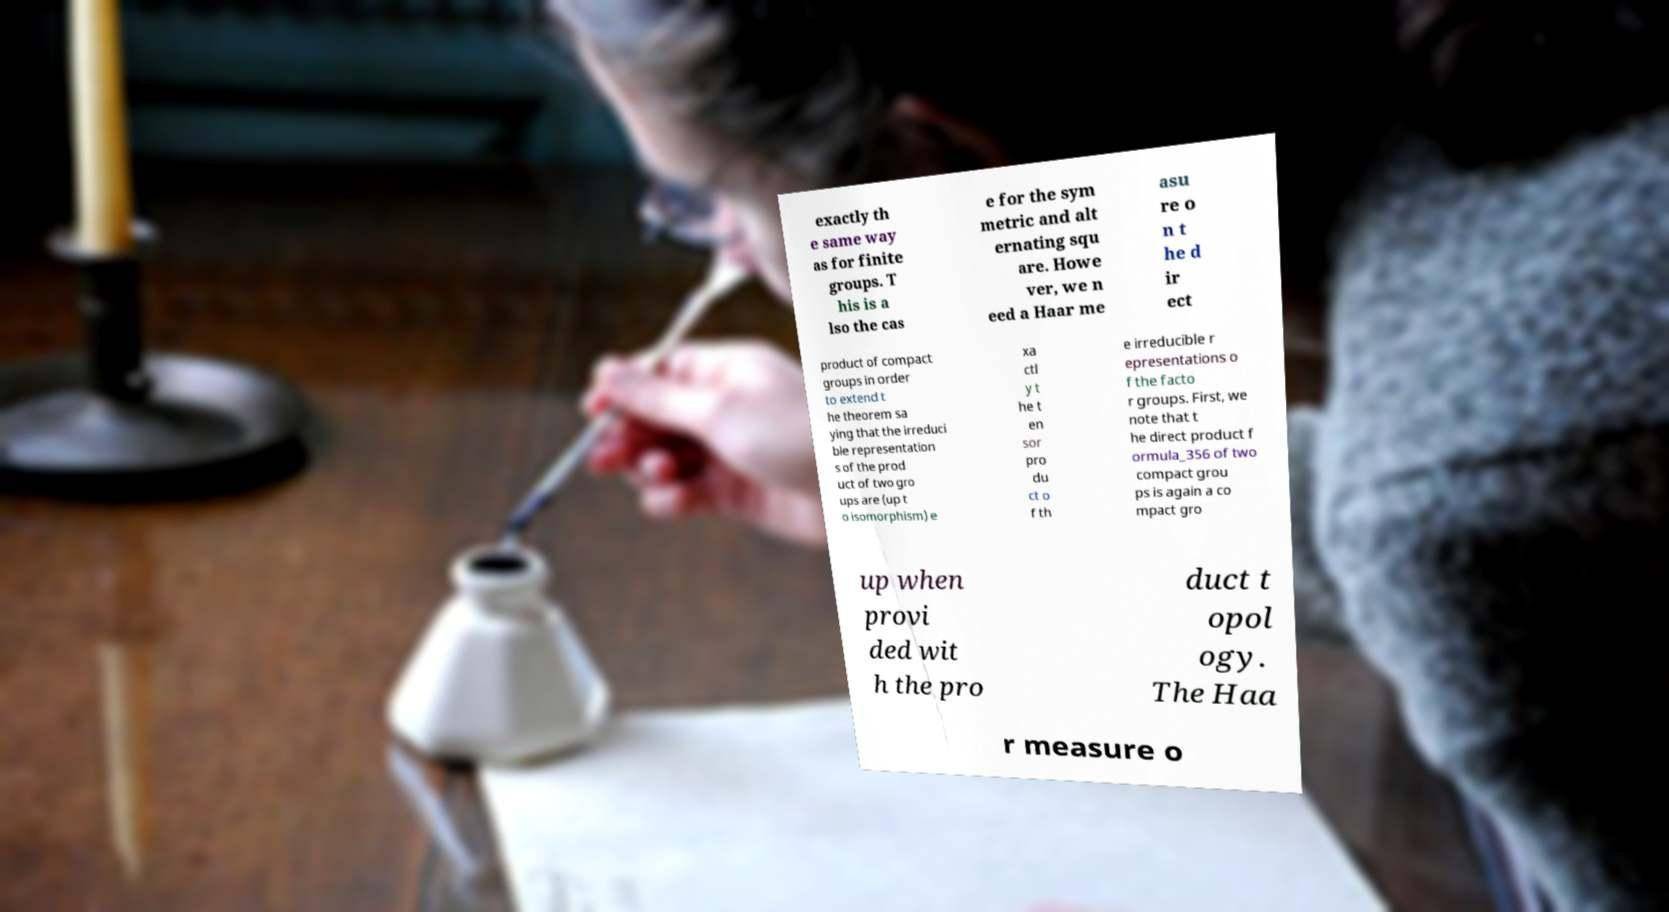For documentation purposes, I need the text within this image transcribed. Could you provide that? exactly th e same way as for finite groups. T his is a lso the cas e for the sym metric and alt ernating squ are. Howe ver, we n eed a Haar me asu re o n t he d ir ect product of compact groups in order to extend t he theorem sa ying that the irreduci ble representation s of the prod uct of two gro ups are (up t o isomorphism) e xa ctl y t he t en sor pro du ct o f th e irreducible r epresentations o f the facto r groups. First, we note that t he direct product f ormula_356 of two compact grou ps is again a co mpact gro up when provi ded wit h the pro duct t opol ogy. The Haa r measure o 